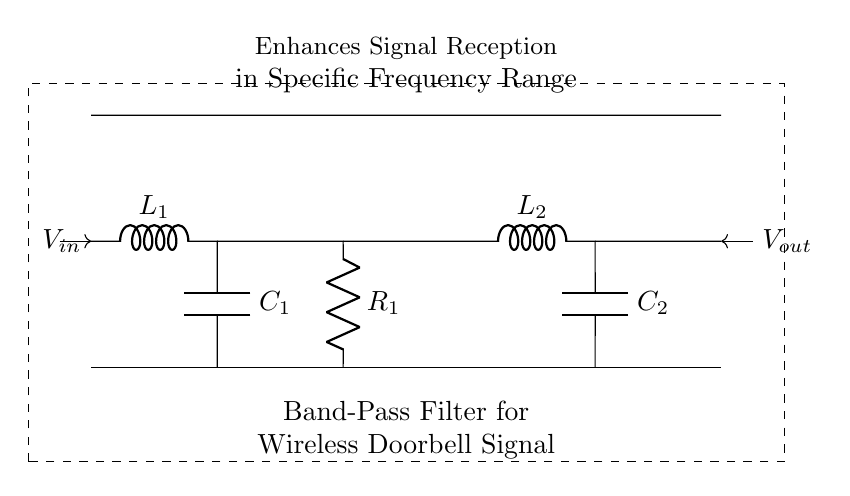What type of filter is shown in the schematic? The circuit diagram depicts a band-pass filter, which allows signals within a certain frequency range to pass while attenuating frequencies outside that range. This is evident from the arrangement of inductors and capacitors designed to create this specific filtering effect.
Answer: Band-pass filter What components are used in the circuit? The circuit consists of two inductors labeled L1 and L2, two capacitors labeled C1 and C2, and a resistor labeled R1. These components combine to form the functionality of the band-pass filter.
Answer: Inductor L1, Inductor L2, Capacitor C1, Capacitor C2, Resistor R1 What is the purpose of the capacitors in this circuit? Capacitors in a band-pass filter serve to block low and high-frequency signals, allowing only a specific frequency range to pass through. They work in conjunction with the inductors to form the frequency-selective behavior of the filter.
Answer: To block undesired frequencies How many inductors are present in the circuit? By observing the circuit, it is clear that there are two inductors, L1 and L2, which play a crucial role in tuning the filter's response to the desired frequency range.
Answer: Two What role does the resistor play in the filter circuit? The resistor regulates the current flow in the circuit and can affect the quality factor (Q) of the filter, which influences the selectivity and bandwidth. Effective selection of resistance affects how the filter responds by damping the circuit, which is crucial for wireless signal clarity.
Answer: Regulates current and affects quality factor In which direction does the input voltage flow? The input voltage flows into the circuit from the left side, indicated by the arrow pointing towards the input voltage node, demonstrating the incoming signal that will be processed by the band-pass filter.
Answer: Left to right 